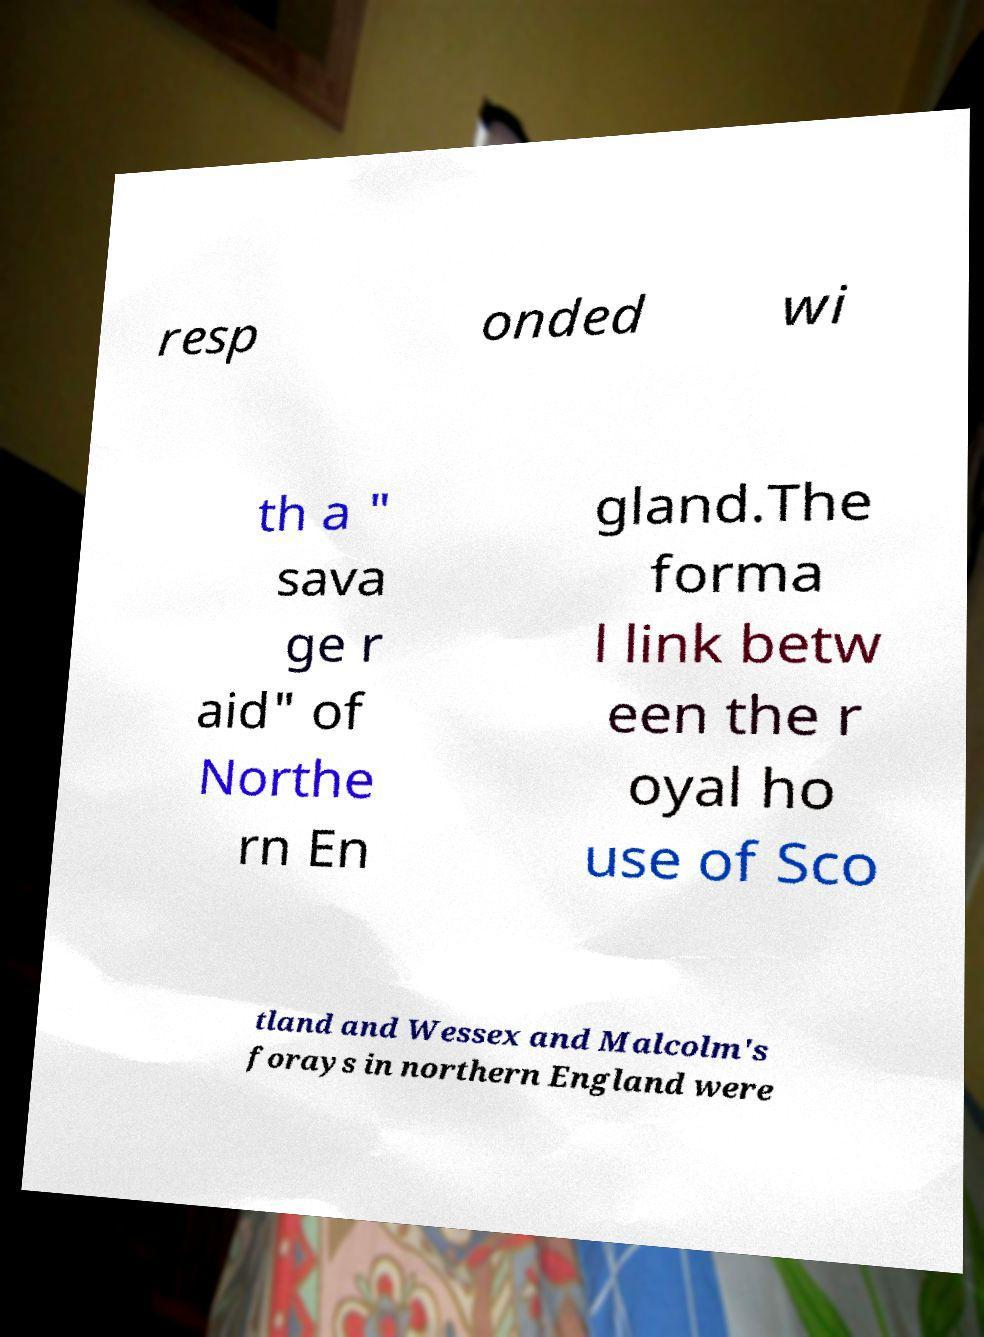Could you extract and type out the text from this image? resp onded wi th a " sava ge r aid" of Northe rn En gland.The forma l link betw een the r oyal ho use of Sco tland and Wessex and Malcolm's forays in northern England were 